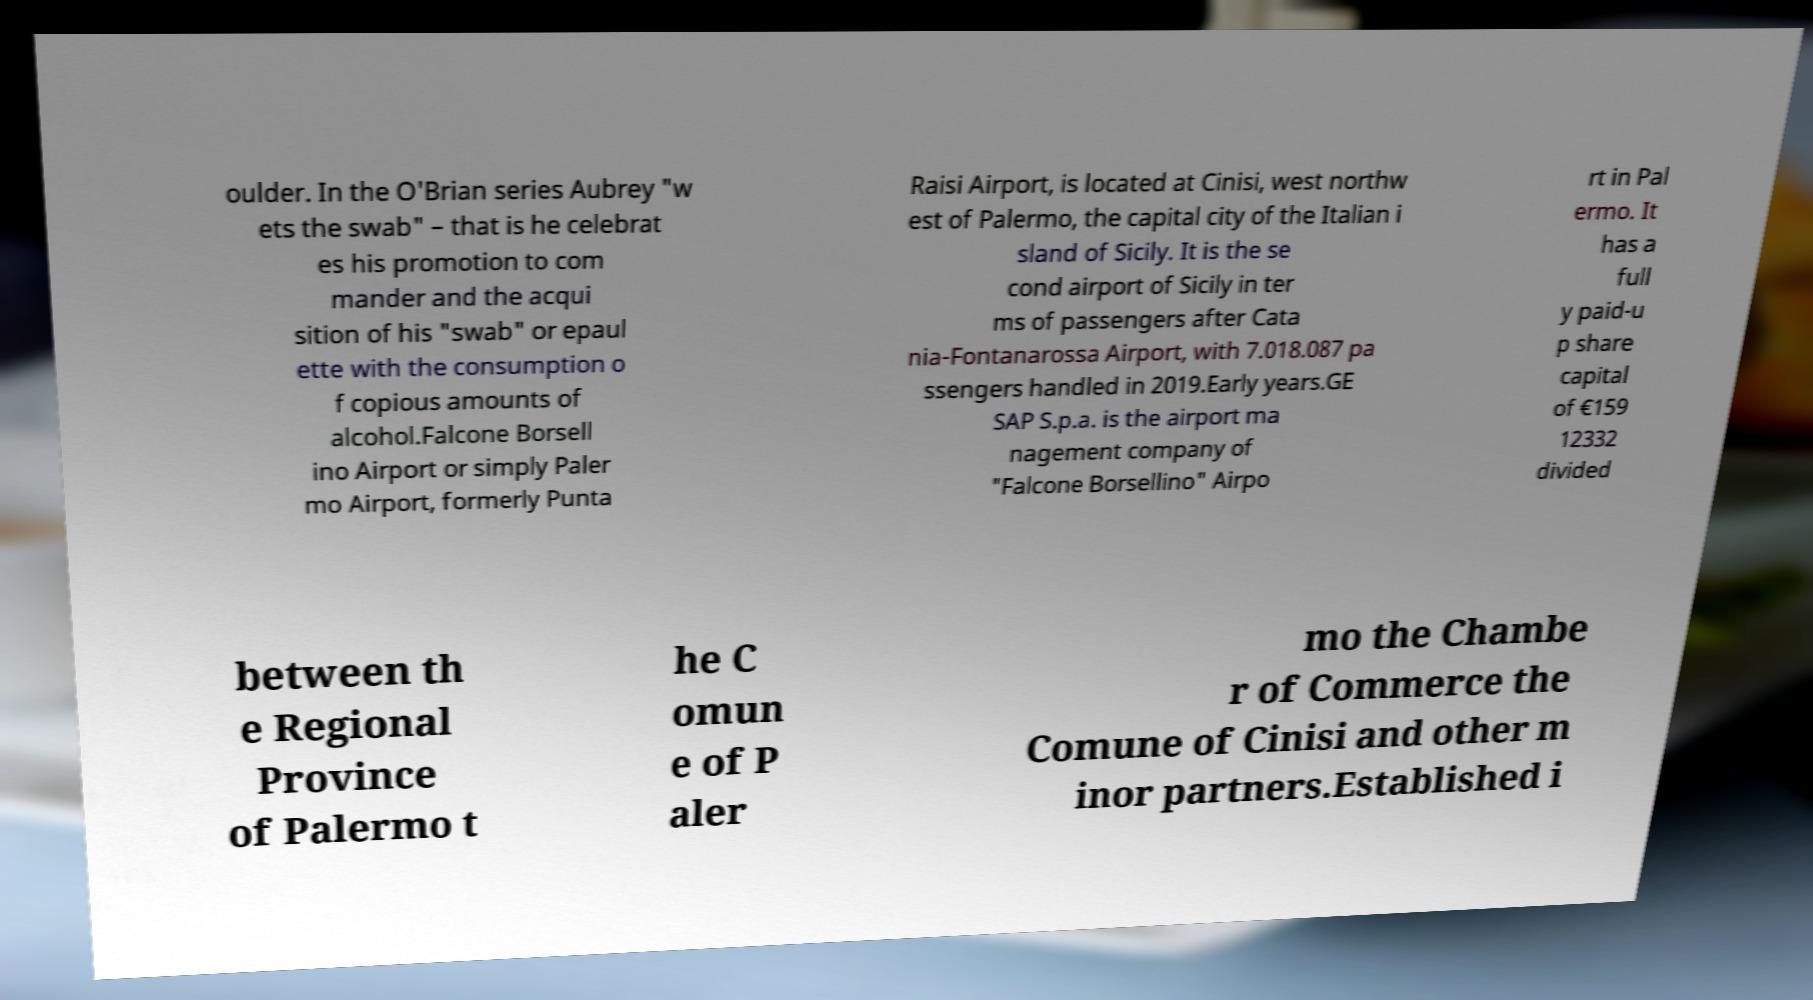Can you read and provide the text displayed in the image?This photo seems to have some interesting text. Can you extract and type it out for me? oulder. In the O'Brian series Aubrey "w ets the swab" – that is he celebrat es his promotion to com mander and the acqui sition of his "swab" or epaul ette with the consumption o f copious amounts of alcohol.Falcone Borsell ino Airport or simply Paler mo Airport, formerly Punta Raisi Airport, is located at Cinisi, west northw est of Palermo, the capital city of the Italian i sland of Sicily. It is the se cond airport of Sicily in ter ms of passengers after Cata nia-Fontanarossa Airport, with 7.018.087 pa ssengers handled in 2019.Early years.GE SAP S.p.a. is the airport ma nagement company of "Falcone Borsellino" Airpo rt in Pal ermo. It has a full y paid-u p share capital of €159 12332 divided between th e Regional Province of Palermo t he C omun e of P aler mo the Chambe r of Commerce the Comune of Cinisi and other m inor partners.Established i 